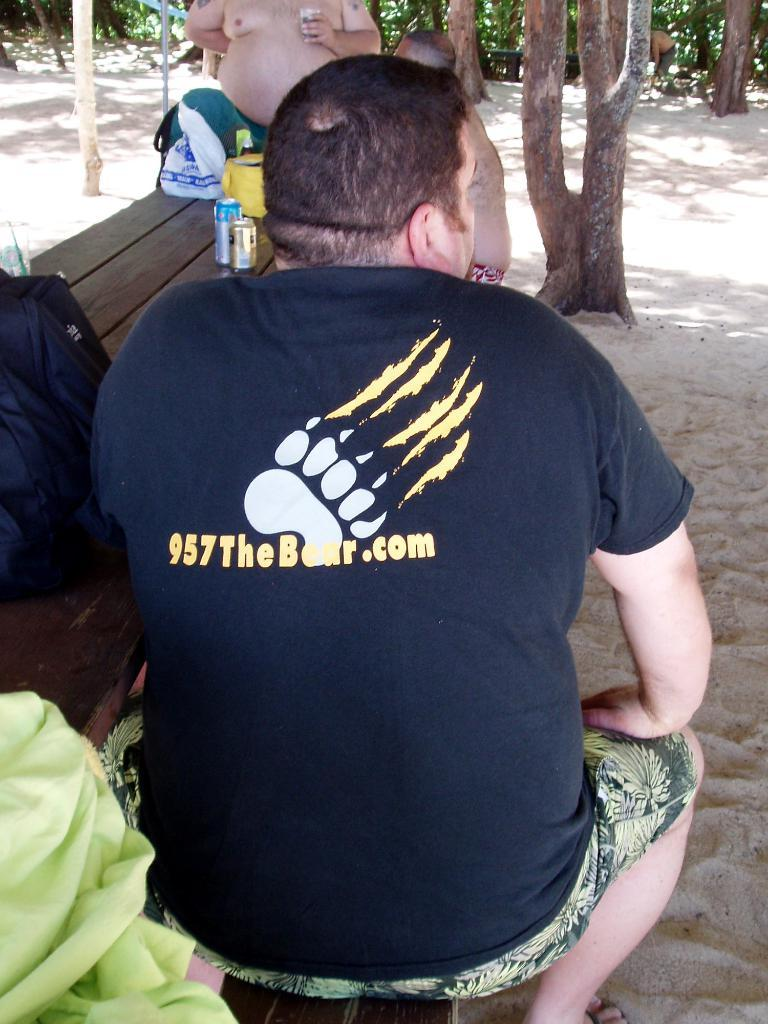What is the man in the image doing? The man is sitting on a bench in the image. Are there any other people in the image? Yes, there are two persons behind the man. What can be seen on a table in the image? There are objects on a table in the image. What is visible in the background of the image? There are trees in the background of the image. What type of honey can be seen dripping from the icicle in the image? There is no honey or icicle present in the image. What color are the bricks on the bench in the image? The image does not show the bench as being made of bricks, so it is not possible to determine the color of any bricks. 